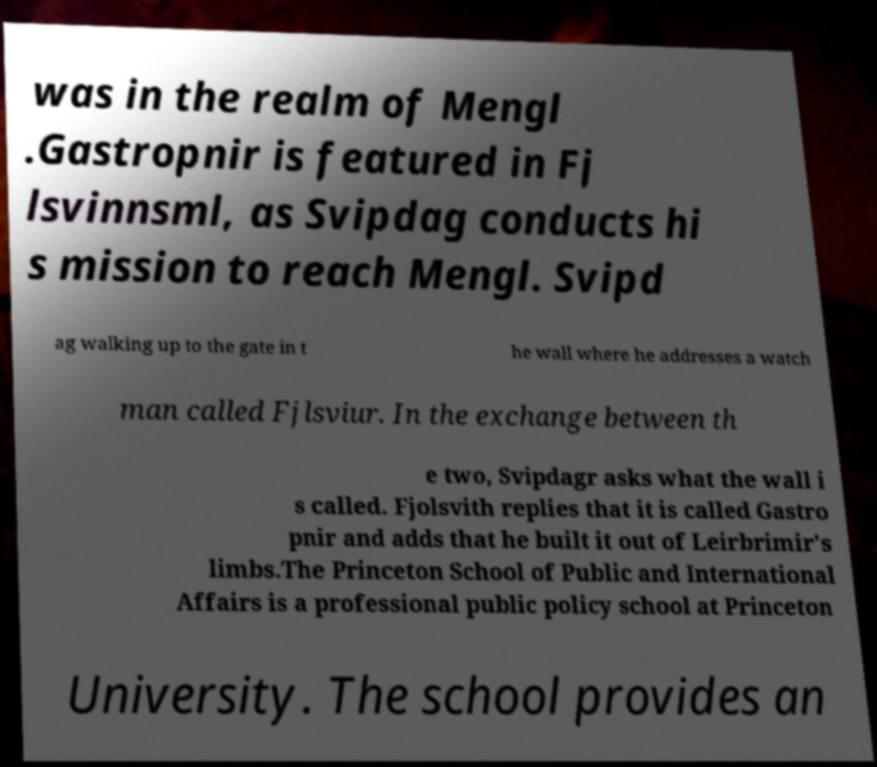Can you accurately transcribe the text from the provided image for me? was in the realm of Mengl .Gastropnir is featured in Fj lsvinnsml, as Svipdag conducts hi s mission to reach Mengl. Svipd ag walking up to the gate in t he wall where he addresses a watch man called Fjlsviur. In the exchange between th e two, Svipdagr asks what the wall i s called. Fjolsvith replies that it is called Gastro pnir and adds that he built it out of Leirbrimir's limbs.The Princeton School of Public and International Affairs is a professional public policy school at Princeton University. The school provides an 